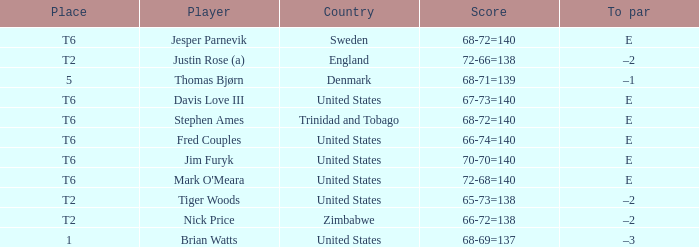What was the TO par for the player who scored 68-71=139? –1. 